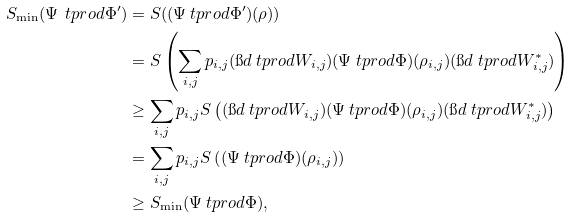<formula> <loc_0><loc_0><loc_500><loc_500>S _ { \min } ( \Psi \ t p r o d \Phi ^ { \prime } ) & = S ( ( \Psi \ t p r o d \Phi ^ { \prime } ) ( \rho ) ) \\ & = S \left ( \sum _ { i , j } p _ { i , j } ( \i d \ t p r o d W _ { i , j } ) ( \Psi \ t p r o d \Phi ) ( \rho _ { i , j } ) ( \i d \ t p r o d W _ { i , j } ^ { * } ) \right ) \\ & \geq \sum _ { i , j } p _ { i , j } S \left ( ( \i d \ t p r o d W _ { i , j } ) ( \Psi \ t p r o d \Phi ) ( \rho _ { i , j } ) ( \i d \ t p r o d W _ { i , j } ^ { * } ) \right ) \\ & = \sum _ { i , j } p _ { i , j } S \left ( ( \Psi \ t p r o d \Phi ) ( \rho _ { i , j } ) \right ) \\ & \geq S _ { \min } ( \Psi \ t p r o d \Phi ) ,</formula> 